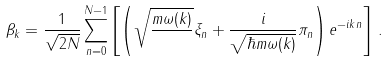Convert formula to latex. <formula><loc_0><loc_0><loc_500><loc_500>\beta _ { k } = \frac { 1 } { \sqrt { 2 N } } \sum _ { n = 0 } ^ { N - 1 } \left [ \left ( \sqrt { \frac { m \omega ( k ) } { } } \xi _ { n } + \frac { i } { \sqrt { \hbar { m } \omega ( k ) } } \pi _ { n } \right ) e ^ { - i k n } \right ] \, .</formula> 